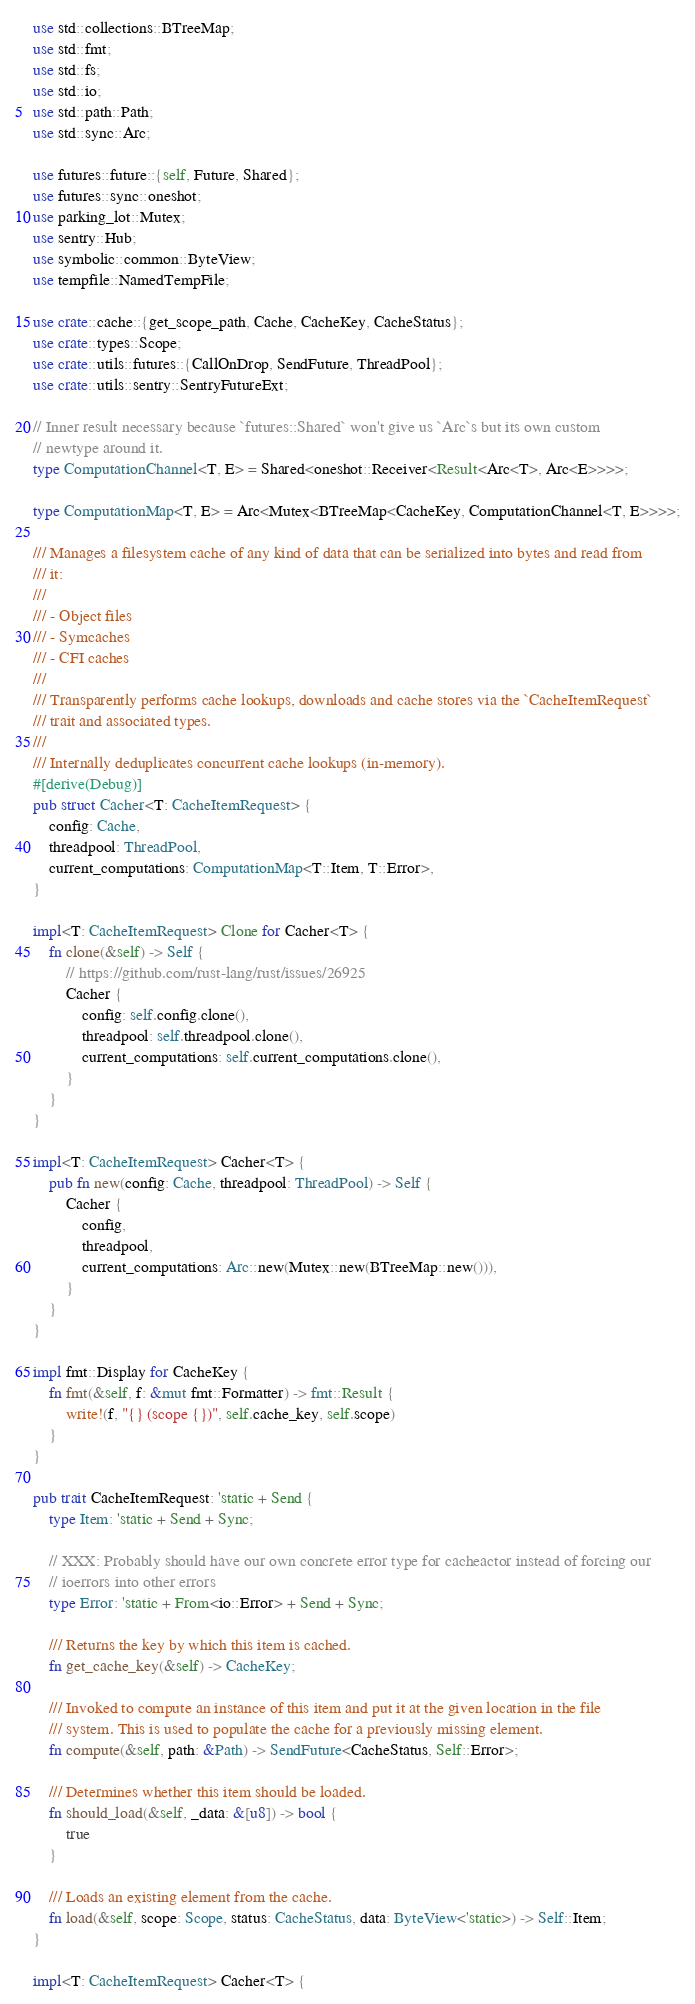<code> <loc_0><loc_0><loc_500><loc_500><_Rust_>use std::collections::BTreeMap;
use std::fmt;
use std::fs;
use std::io;
use std::path::Path;
use std::sync::Arc;

use futures::future::{self, Future, Shared};
use futures::sync::oneshot;
use parking_lot::Mutex;
use sentry::Hub;
use symbolic::common::ByteView;
use tempfile::NamedTempFile;

use crate::cache::{get_scope_path, Cache, CacheKey, CacheStatus};
use crate::types::Scope;
use crate::utils::futures::{CallOnDrop, SendFuture, ThreadPool};
use crate::utils::sentry::SentryFutureExt;

// Inner result necessary because `futures::Shared` won't give us `Arc`s but its own custom
// newtype around it.
type ComputationChannel<T, E> = Shared<oneshot::Receiver<Result<Arc<T>, Arc<E>>>>;

type ComputationMap<T, E> = Arc<Mutex<BTreeMap<CacheKey, ComputationChannel<T, E>>>>;

/// Manages a filesystem cache of any kind of data that can be serialized into bytes and read from
/// it:
///
/// - Object files
/// - Symcaches
/// - CFI caches
///
/// Transparently performs cache lookups, downloads and cache stores via the `CacheItemRequest`
/// trait and associated types.
///
/// Internally deduplicates concurrent cache lookups (in-memory).
#[derive(Debug)]
pub struct Cacher<T: CacheItemRequest> {
    config: Cache,
    threadpool: ThreadPool,
    current_computations: ComputationMap<T::Item, T::Error>,
}

impl<T: CacheItemRequest> Clone for Cacher<T> {
    fn clone(&self) -> Self {
        // https://github.com/rust-lang/rust/issues/26925
        Cacher {
            config: self.config.clone(),
            threadpool: self.threadpool.clone(),
            current_computations: self.current_computations.clone(),
        }
    }
}

impl<T: CacheItemRequest> Cacher<T> {
    pub fn new(config: Cache, threadpool: ThreadPool) -> Self {
        Cacher {
            config,
            threadpool,
            current_computations: Arc::new(Mutex::new(BTreeMap::new())),
        }
    }
}

impl fmt::Display for CacheKey {
    fn fmt(&self, f: &mut fmt::Formatter) -> fmt::Result {
        write!(f, "{} (scope {})", self.cache_key, self.scope)
    }
}

pub trait CacheItemRequest: 'static + Send {
    type Item: 'static + Send + Sync;

    // XXX: Probably should have our own concrete error type for cacheactor instead of forcing our
    // ioerrors into other errors
    type Error: 'static + From<io::Error> + Send + Sync;

    /// Returns the key by which this item is cached.
    fn get_cache_key(&self) -> CacheKey;

    /// Invoked to compute an instance of this item and put it at the given location in the file
    /// system. This is used to populate the cache for a previously missing element.
    fn compute(&self, path: &Path) -> SendFuture<CacheStatus, Self::Error>;

    /// Determines whether this item should be loaded.
    fn should_load(&self, _data: &[u8]) -> bool {
        true
    }

    /// Loads an existing element from the cache.
    fn load(&self, scope: Scope, status: CacheStatus, data: ByteView<'static>) -> Self::Item;
}

impl<T: CacheItemRequest> Cacher<T> {</code> 